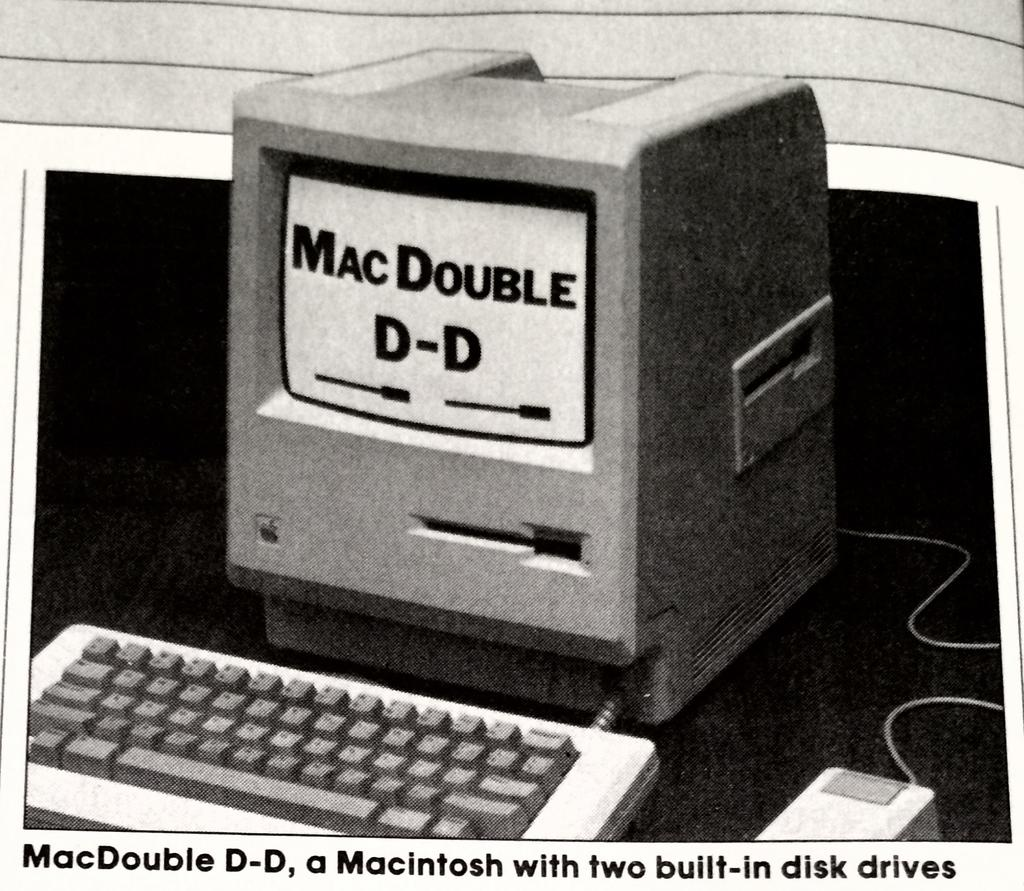<image>
Relay a brief, clear account of the picture shown. A Mac Double D-D computer with built in disk drives. 